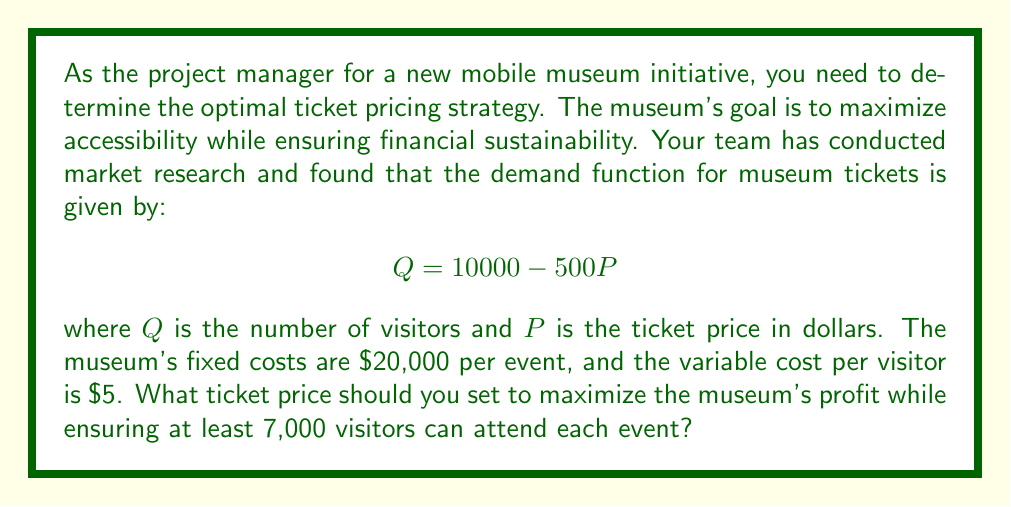Solve this math problem. To solve this problem, we'll follow these steps:

1) First, let's define the profit function:
   $$\text{Profit} = \text{Revenue} - \text{Total Costs}$$
   $$\pi = PQ - (FC + VC \cdot Q)$$

   Where $FC$ is fixed costs and $VC$ is variable cost per visitor.

2) Substitute the given values:
   $$\pi = P(10000 - 500P) - (20000 + 5(10000 - 500P))$$

3) Expand the equation:
   $$\pi = 10000P - 500P^2 - 20000 - 50000 + 2500P$$
   $$\pi = -500P^2 + 12500P - 70000$$

4) To maximize profit, we would typically find where $\frac{d\pi}{dP} = 0$. However, we also need to ensure at least 7,000 visitors.

5) From the demand function, to have 7,000 visitors:
   $$7000 = 10000 - 500P$$
   $$3000 = 500P$$
   $$P = 6$$

6) So, our maximum price is $6. Let's check if this gives the maximum profit within our constraint:

   At $P = 6$:
   $$\pi = -500(6)^2 + 12500(6) - 70000 = 5000$$

7) Let's compare this with prices slightly below $6:

   At $P = 5.5$:
   $$\pi = -500(5.5)^2 + 12500(5.5) - 70000 = 5312.5$$

   At $P = 5$:
   $$\pi = -500(5)^2 + 12500(5) - 70000 = 5000$$

8) We can see that the maximum profit within our constraint occurs at $P = 5.5$.
Answer: The optimal ticket price to maximize profit while ensuring at least 7,000 visitors is $5.50. 